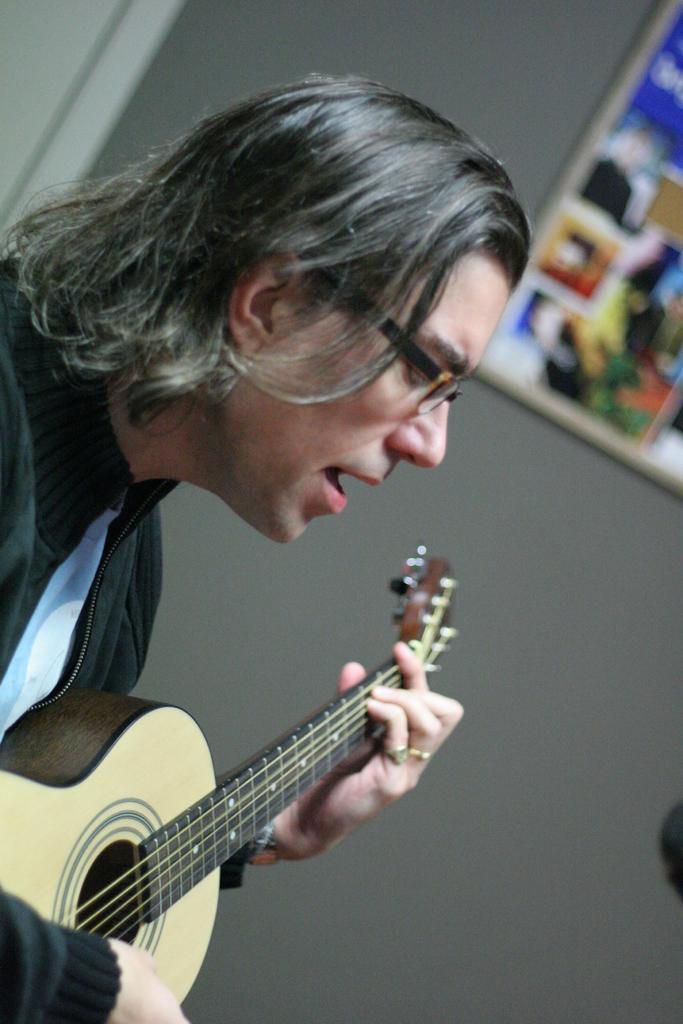Describe this image in one or two sentences. In this image I can see a person holding guitar. At the back side there is a frame and a grey wall. 